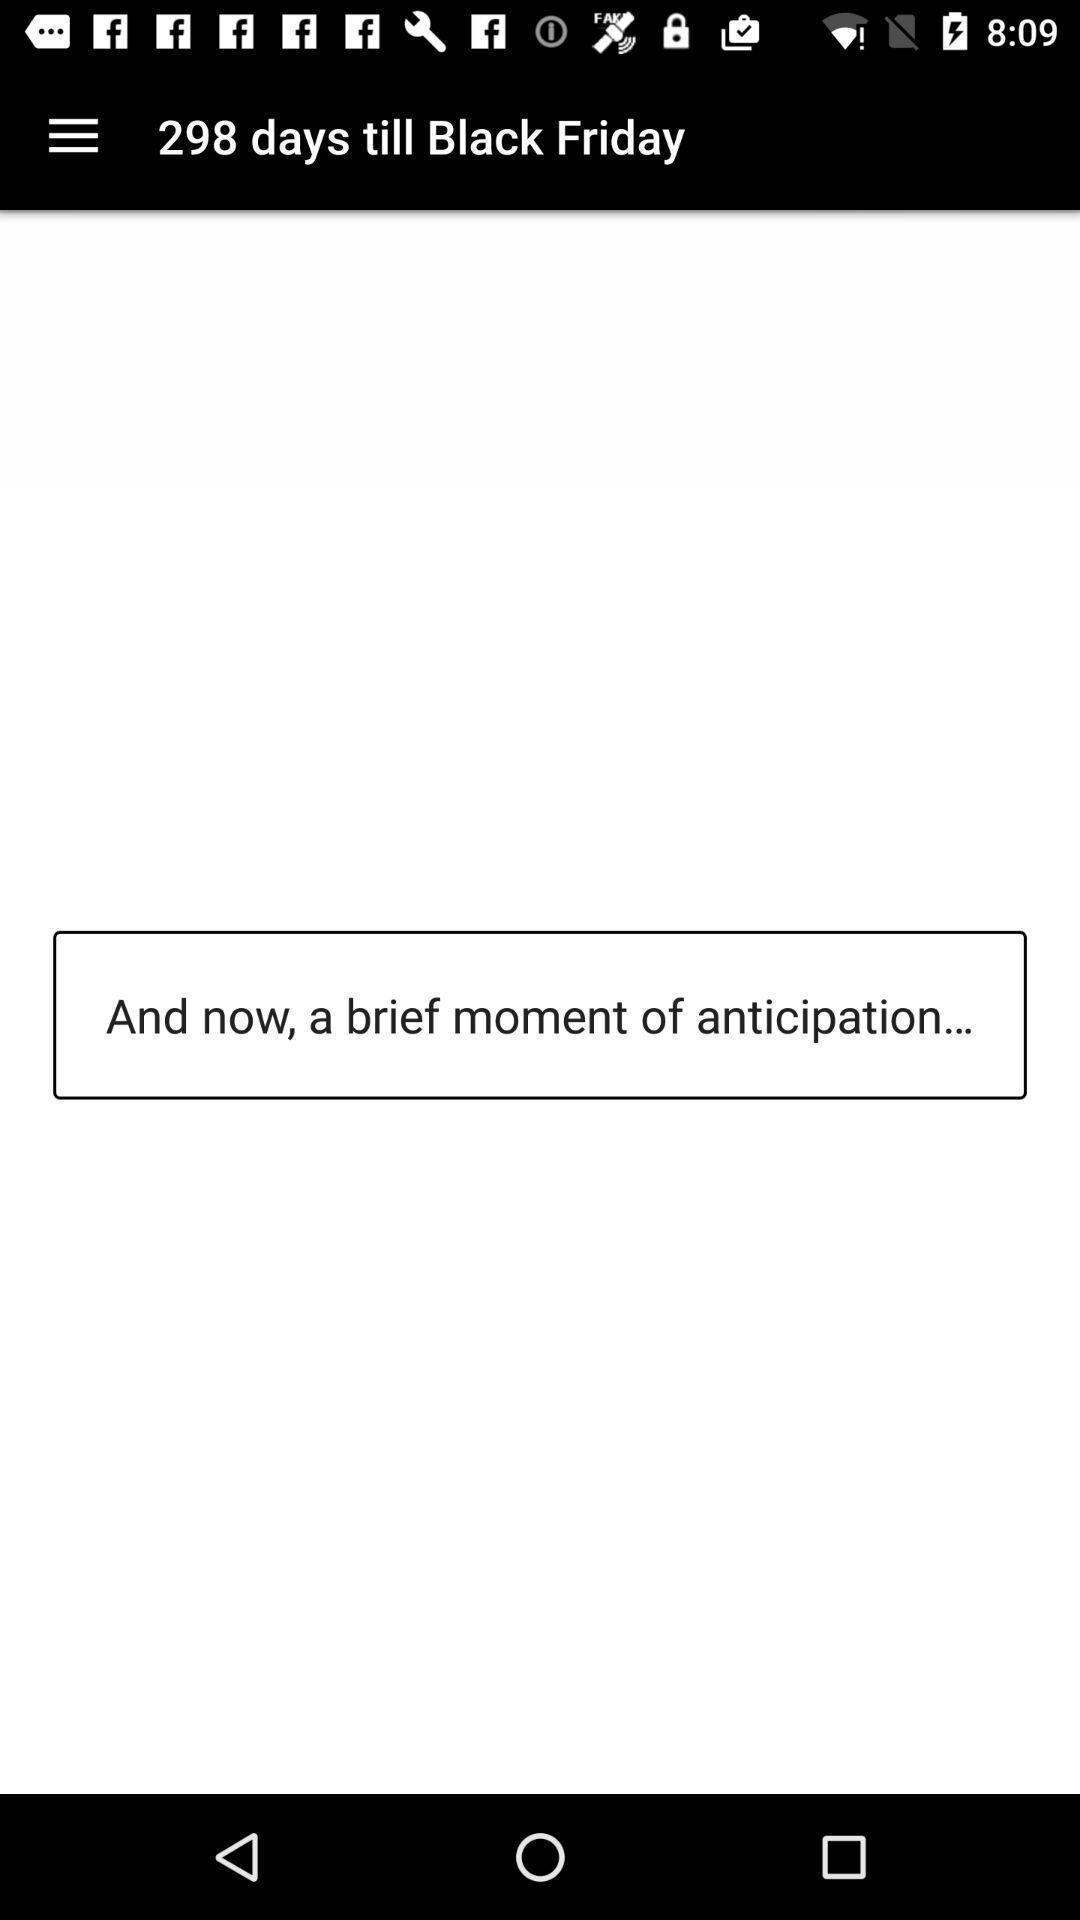Describe the visual elements of this screenshot. Screen shows 298 days till black friday. 